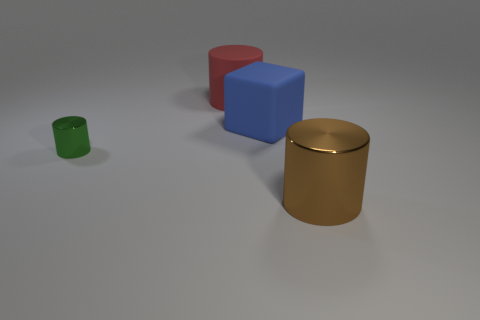Is the number of big yellow rubber balls the same as the number of red matte cylinders?
Offer a terse response. No. Do the matte cylinder and the blue thing have the same size?
Give a very brief answer. Yes. There is a metal cylinder to the left of the metal object that is to the right of the rubber cylinder; are there any green objects that are to the left of it?
Your response must be concise. No. How big is the rubber block?
Keep it short and to the point. Large. What number of blue cubes are the same size as the brown cylinder?
Your answer should be very brief. 1. What material is the green object that is the same shape as the brown metal thing?
Ensure brevity in your answer.  Metal. There is a object that is both on the left side of the big blue block and in front of the matte cube; what shape is it?
Provide a short and direct response. Cylinder. What shape is the thing that is behind the big blue object?
Keep it short and to the point. Cylinder. How many big cylinders are both to the right of the large cube and behind the tiny shiny thing?
Ensure brevity in your answer.  0. There is a blue object; is its size the same as the shiny cylinder left of the big blue rubber block?
Offer a terse response. No. 